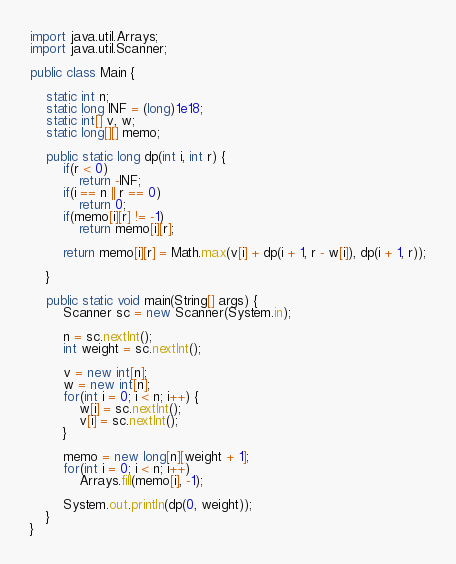<code> <loc_0><loc_0><loc_500><loc_500><_Java_>import java.util.Arrays;
import java.util.Scanner;

public class Main {
	
	static int n;
	static long INF = (long)1e18;
	static int[] v, w;
	static long[][] memo;
	
	public static long dp(int i, int r) {
		if(r < 0)
			return -INF;
		if(i == n || r == 0)
			return 0;
		if(memo[i][r] != -1)
			return memo[i][r];
		
		return memo[i][r] = Math.max(v[i] + dp(i + 1, r - w[i]), dp(i + 1, r));
		
	}
	
	public static void main(String[] args) {
		Scanner sc = new Scanner(System.in);
		
		n = sc.nextInt();
		int weight = sc.nextInt();
		
		v = new int[n];
		w = new int[n];
		for(int i = 0; i < n; i++) {
			w[i] = sc.nextInt();
			v[i] = sc.nextInt();
		}
		
		memo = new long[n][weight + 1];
		for(int i = 0; i < n; i++)
			Arrays.fill(memo[i], -1);
		
		System.out.println(dp(0, weight));
	}
}
</code> 